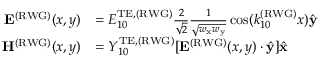Convert formula to latex. <formula><loc_0><loc_0><loc_500><loc_500>\begin{array} { r l } { E ^ { ( R W G ) } ( x , y ) } & { = E _ { 1 0 } ^ { T E , ( R W G ) } \frac { 2 } { \sqrt { 2 } } \frac { 1 } { \sqrt { w _ { x } w _ { y } } } \cos ( k _ { 1 0 } ^ { ( R W G ) } x ) \hat { y } } \\ { H ^ { ( R W G ) } ( x , y ) } & { = Y _ { 1 0 } ^ { T E , ( R W G ) } [ E ^ { ( R W G ) } ( x , y ) \cdot \hat { y } ] \hat { x } } \end{array}</formula> 